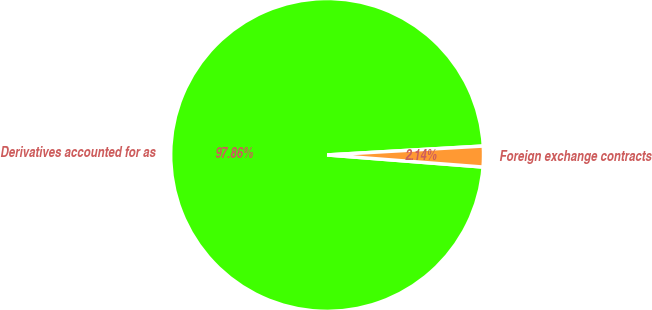<chart> <loc_0><loc_0><loc_500><loc_500><pie_chart><fcel>Derivatives accounted for as<fcel>Foreign exchange contracts<nl><fcel>97.86%<fcel>2.14%<nl></chart> 